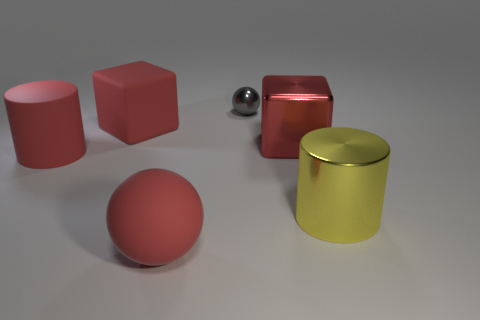Add 4 big green metallic balls. How many objects exist? 10 Subtract all blocks. How many objects are left? 4 Add 4 spheres. How many spheres exist? 6 Subtract 1 red balls. How many objects are left? 5 Subtract all large red matte cylinders. Subtract all blocks. How many objects are left? 3 Add 2 small shiny spheres. How many small shiny spheres are left? 3 